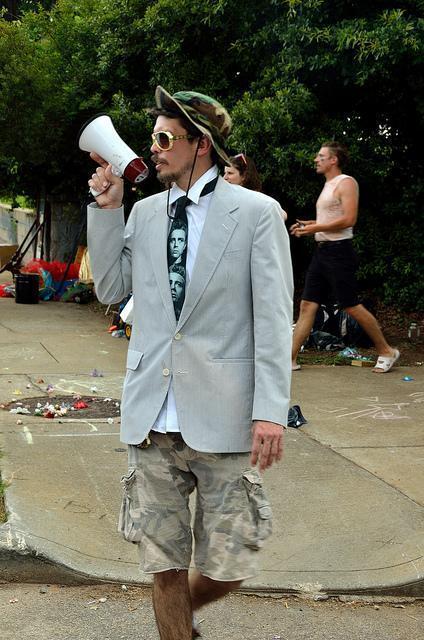How many people are there?
Give a very brief answer. 2. 